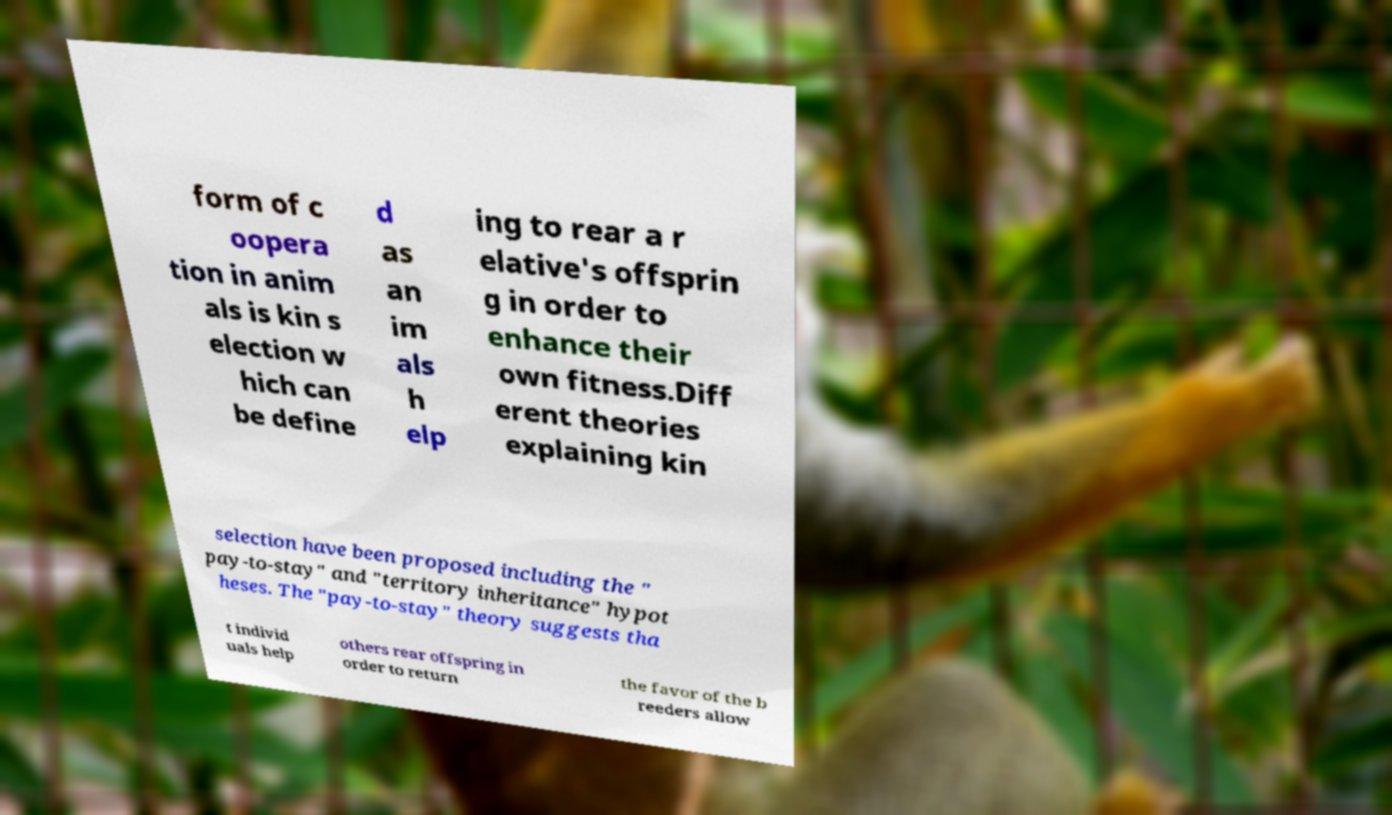Could you extract and type out the text from this image? form of c oopera tion in anim als is kin s election w hich can be define d as an im als h elp ing to rear a r elative's offsprin g in order to enhance their own fitness.Diff erent theories explaining kin selection have been proposed including the " pay-to-stay" and "territory inheritance" hypot heses. The "pay-to-stay" theory suggests tha t individ uals help others rear offspring in order to return the favor of the b reeders allow 